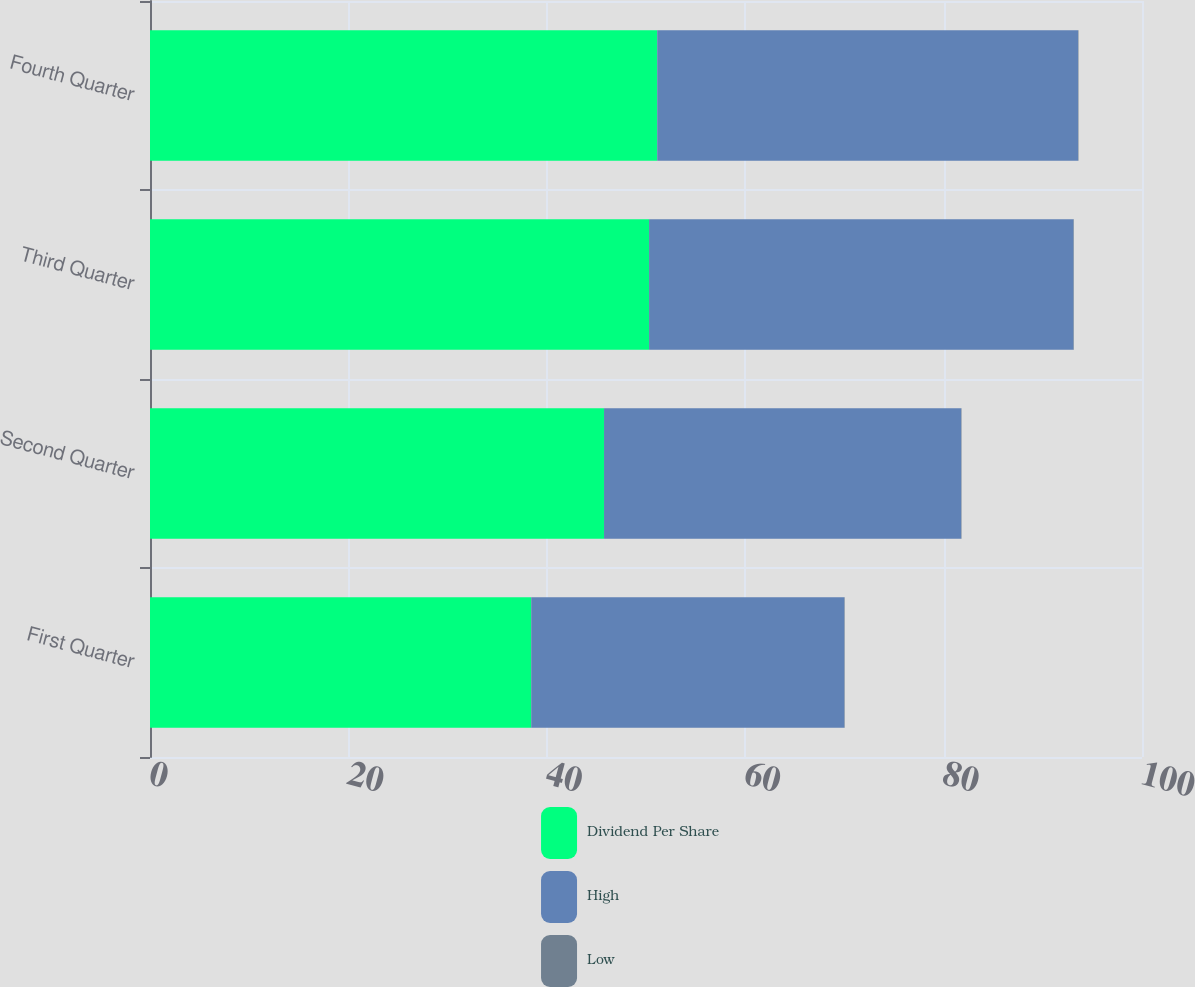Convert chart. <chart><loc_0><loc_0><loc_500><loc_500><stacked_bar_chart><ecel><fcel>First Quarter<fcel>Second Quarter<fcel>Third Quarter<fcel>Fourth Quarter<nl><fcel>Dividend Per Share<fcel>38.43<fcel>45.77<fcel>50.31<fcel>51.13<nl><fcel>High<fcel>31.57<fcel>36<fcel>42.79<fcel>42.43<nl><fcel>Low<fcel>0.04<fcel>0.04<fcel>0.04<fcel>0.04<nl></chart> 